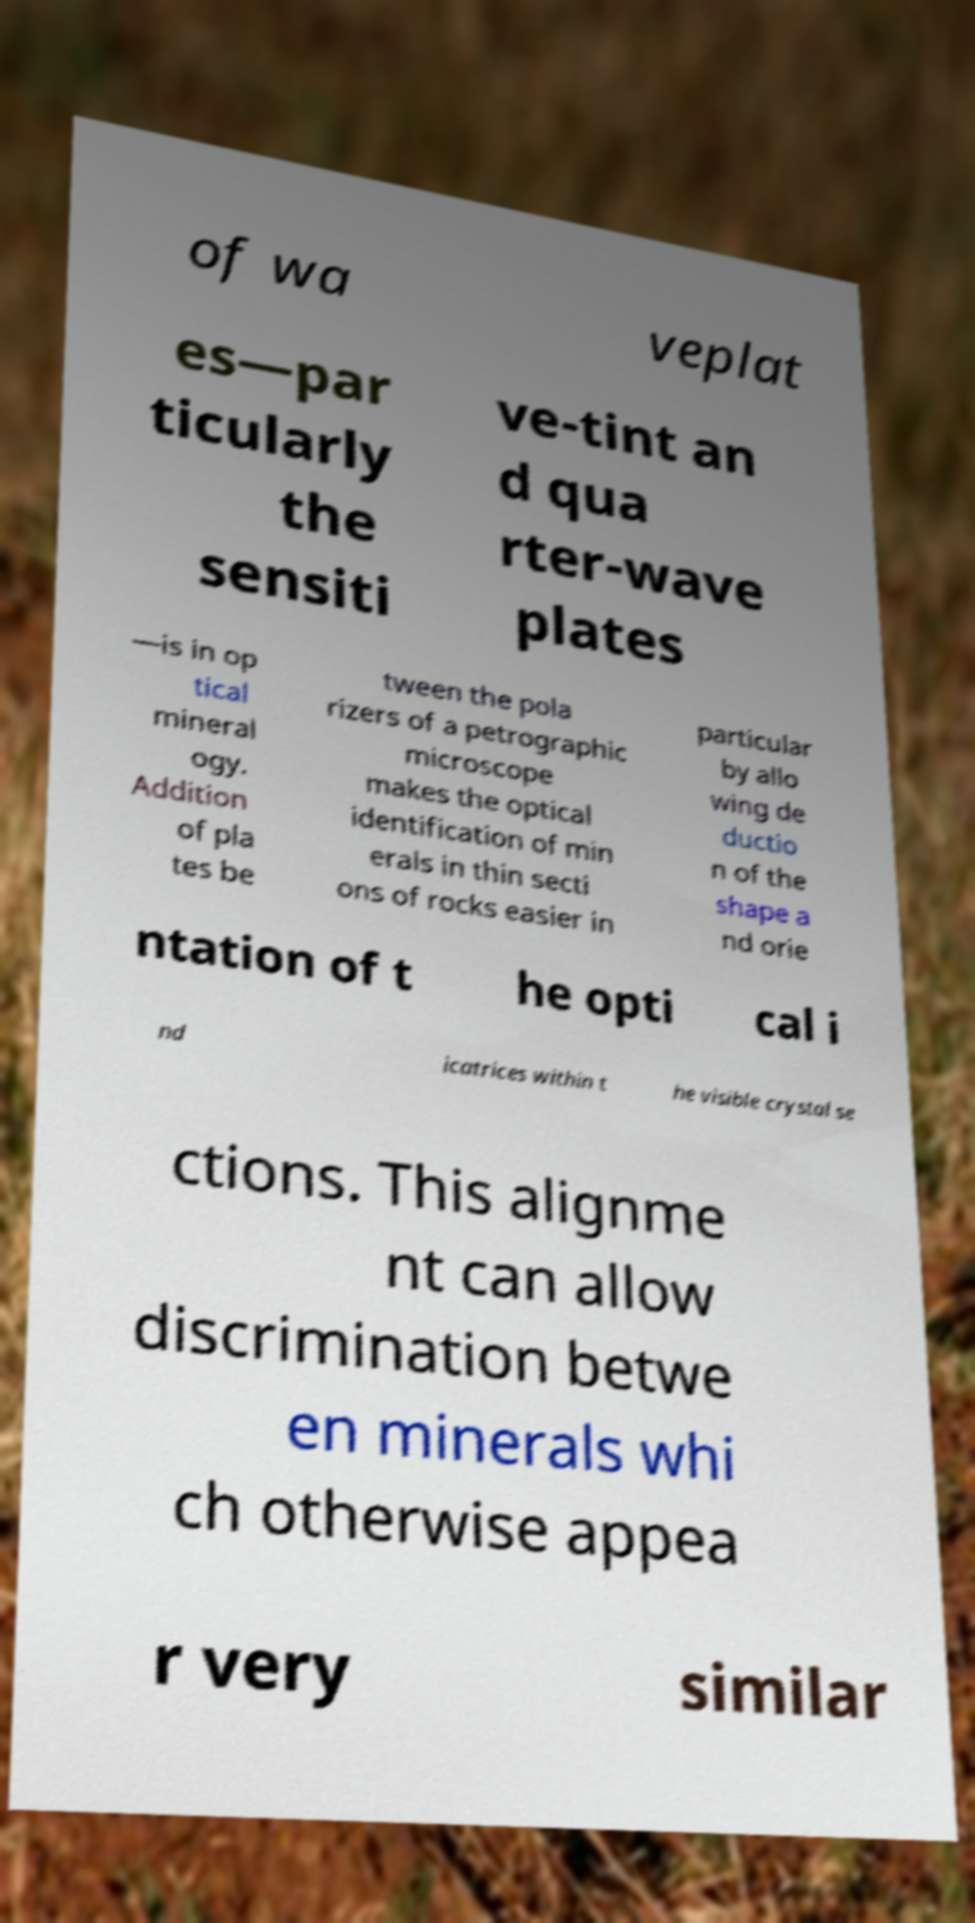Could you assist in decoding the text presented in this image and type it out clearly? of wa veplat es—par ticularly the sensiti ve-tint an d qua rter-wave plates —is in op tical mineral ogy. Addition of pla tes be tween the pola rizers of a petrographic microscope makes the optical identification of min erals in thin secti ons of rocks easier in particular by allo wing de ductio n of the shape a nd orie ntation of t he opti cal i nd icatrices within t he visible crystal se ctions. This alignme nt can allow discrimination betwe en minerals whi ch otherwise appea r very similar 